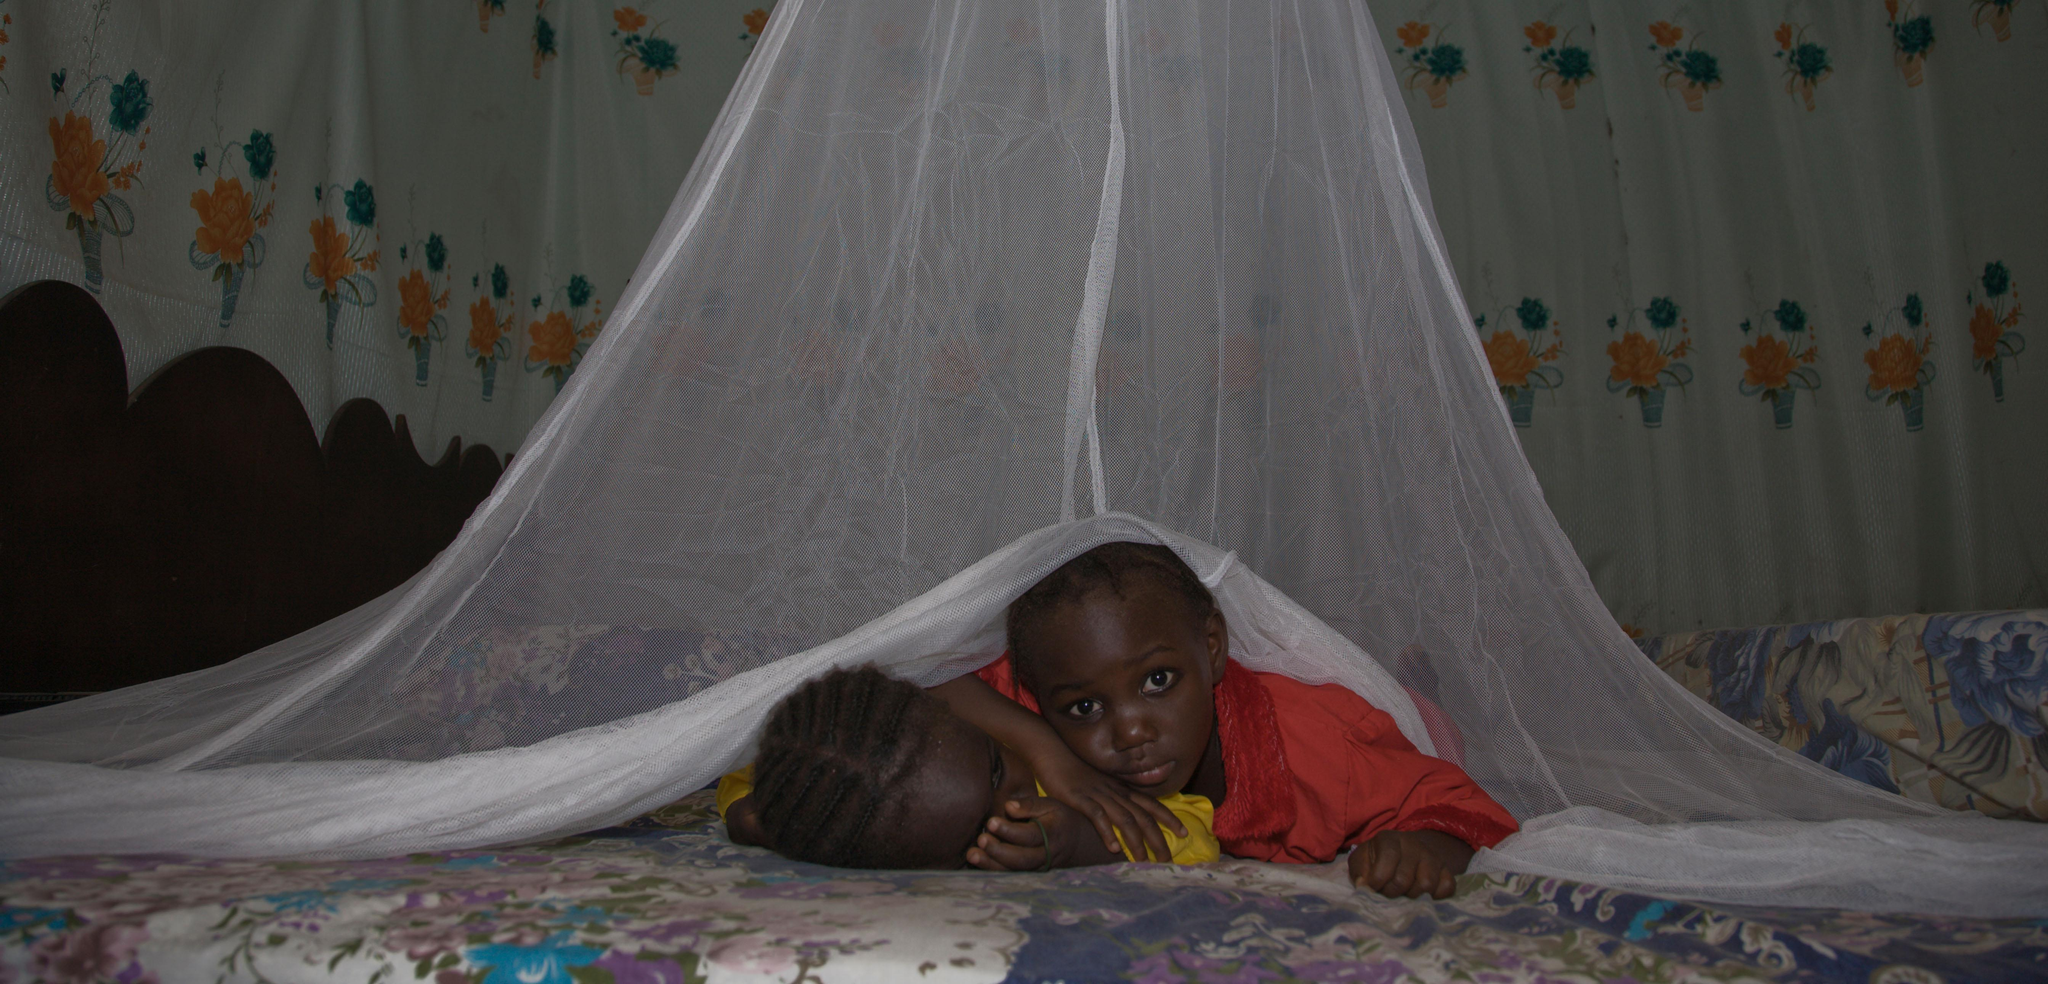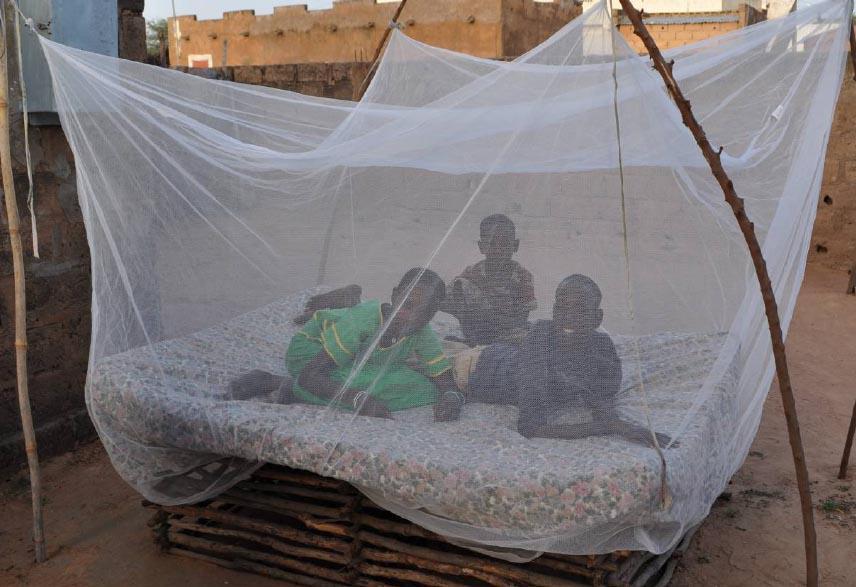The first image is the image on the left, the second image is the image on the right. Evaluate the accuracy of this statement regarding the images: "There are two canopies with at least two child.". Is it true? Answer yes or no. Yes. The first image is the image on the left, the second image is the image on the right. Assess this claim about the two images: "There is at least one child in each bed.". Correct or not? Answer yes or no. Yes. 